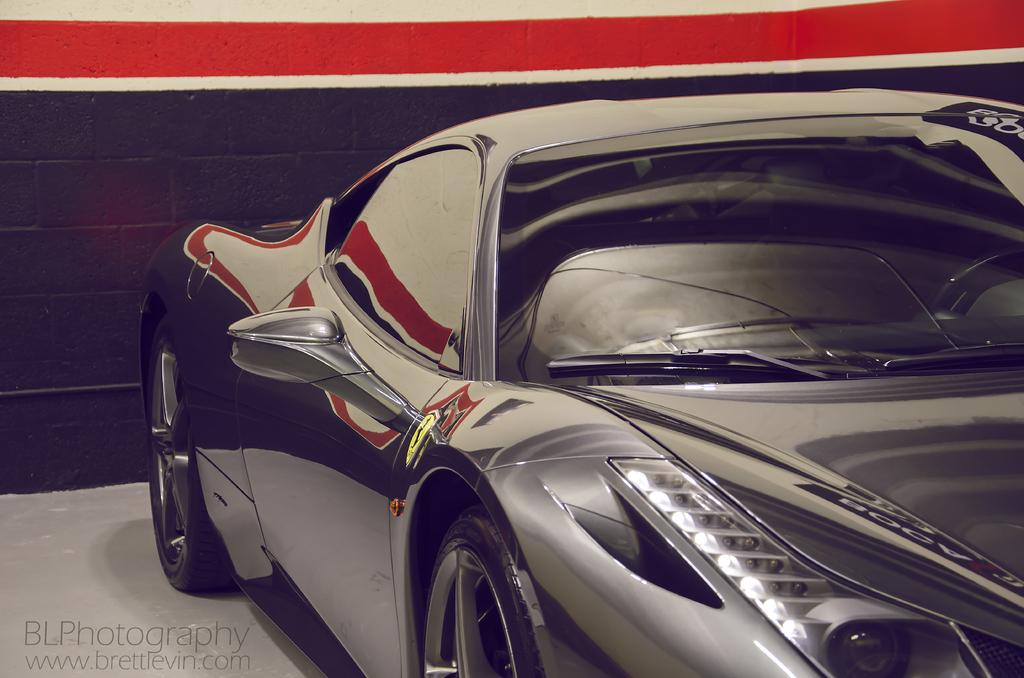What is the main subject of the image? There is a car in the image. Can you describe the color of the car? The car is black in color. What is located behind the car in the image? There is a wall behind the car. What colors are used for the wall in the image? The wall is black and red in color. What type of oranges can be seen hanging from the wall in the image? There are no oranges present in the image; the wall is black and red in color. What cast members are visible in the image? There are no cast members present in the image; it features a car and a wall. 